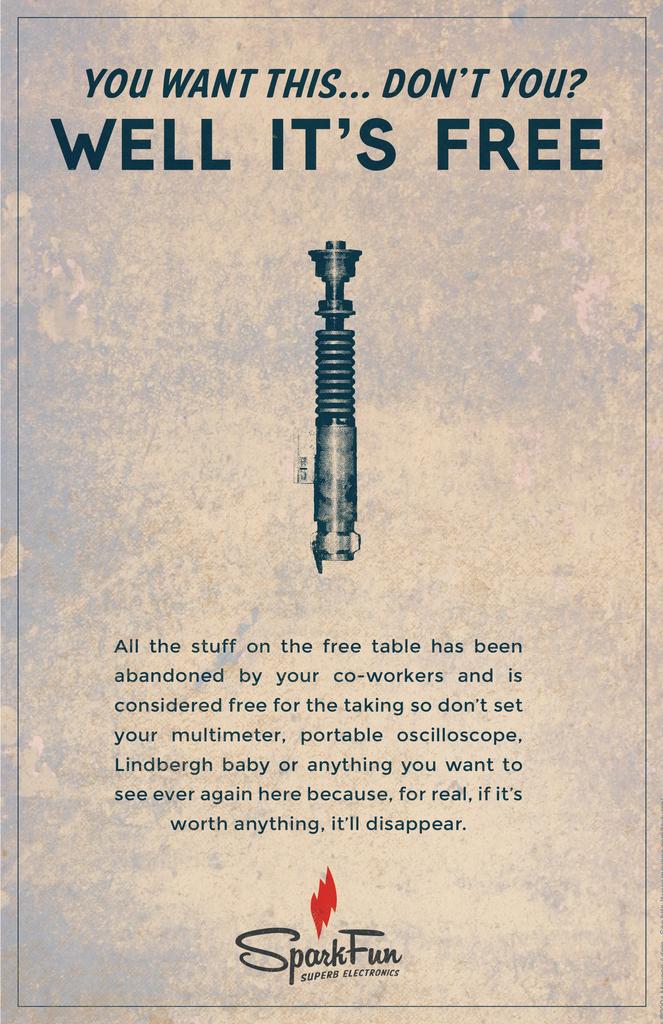Well it's what?
Offer a terse response. Free. What is the brand on this advertisement?
Keep it short and to the point. Sparkfun. 